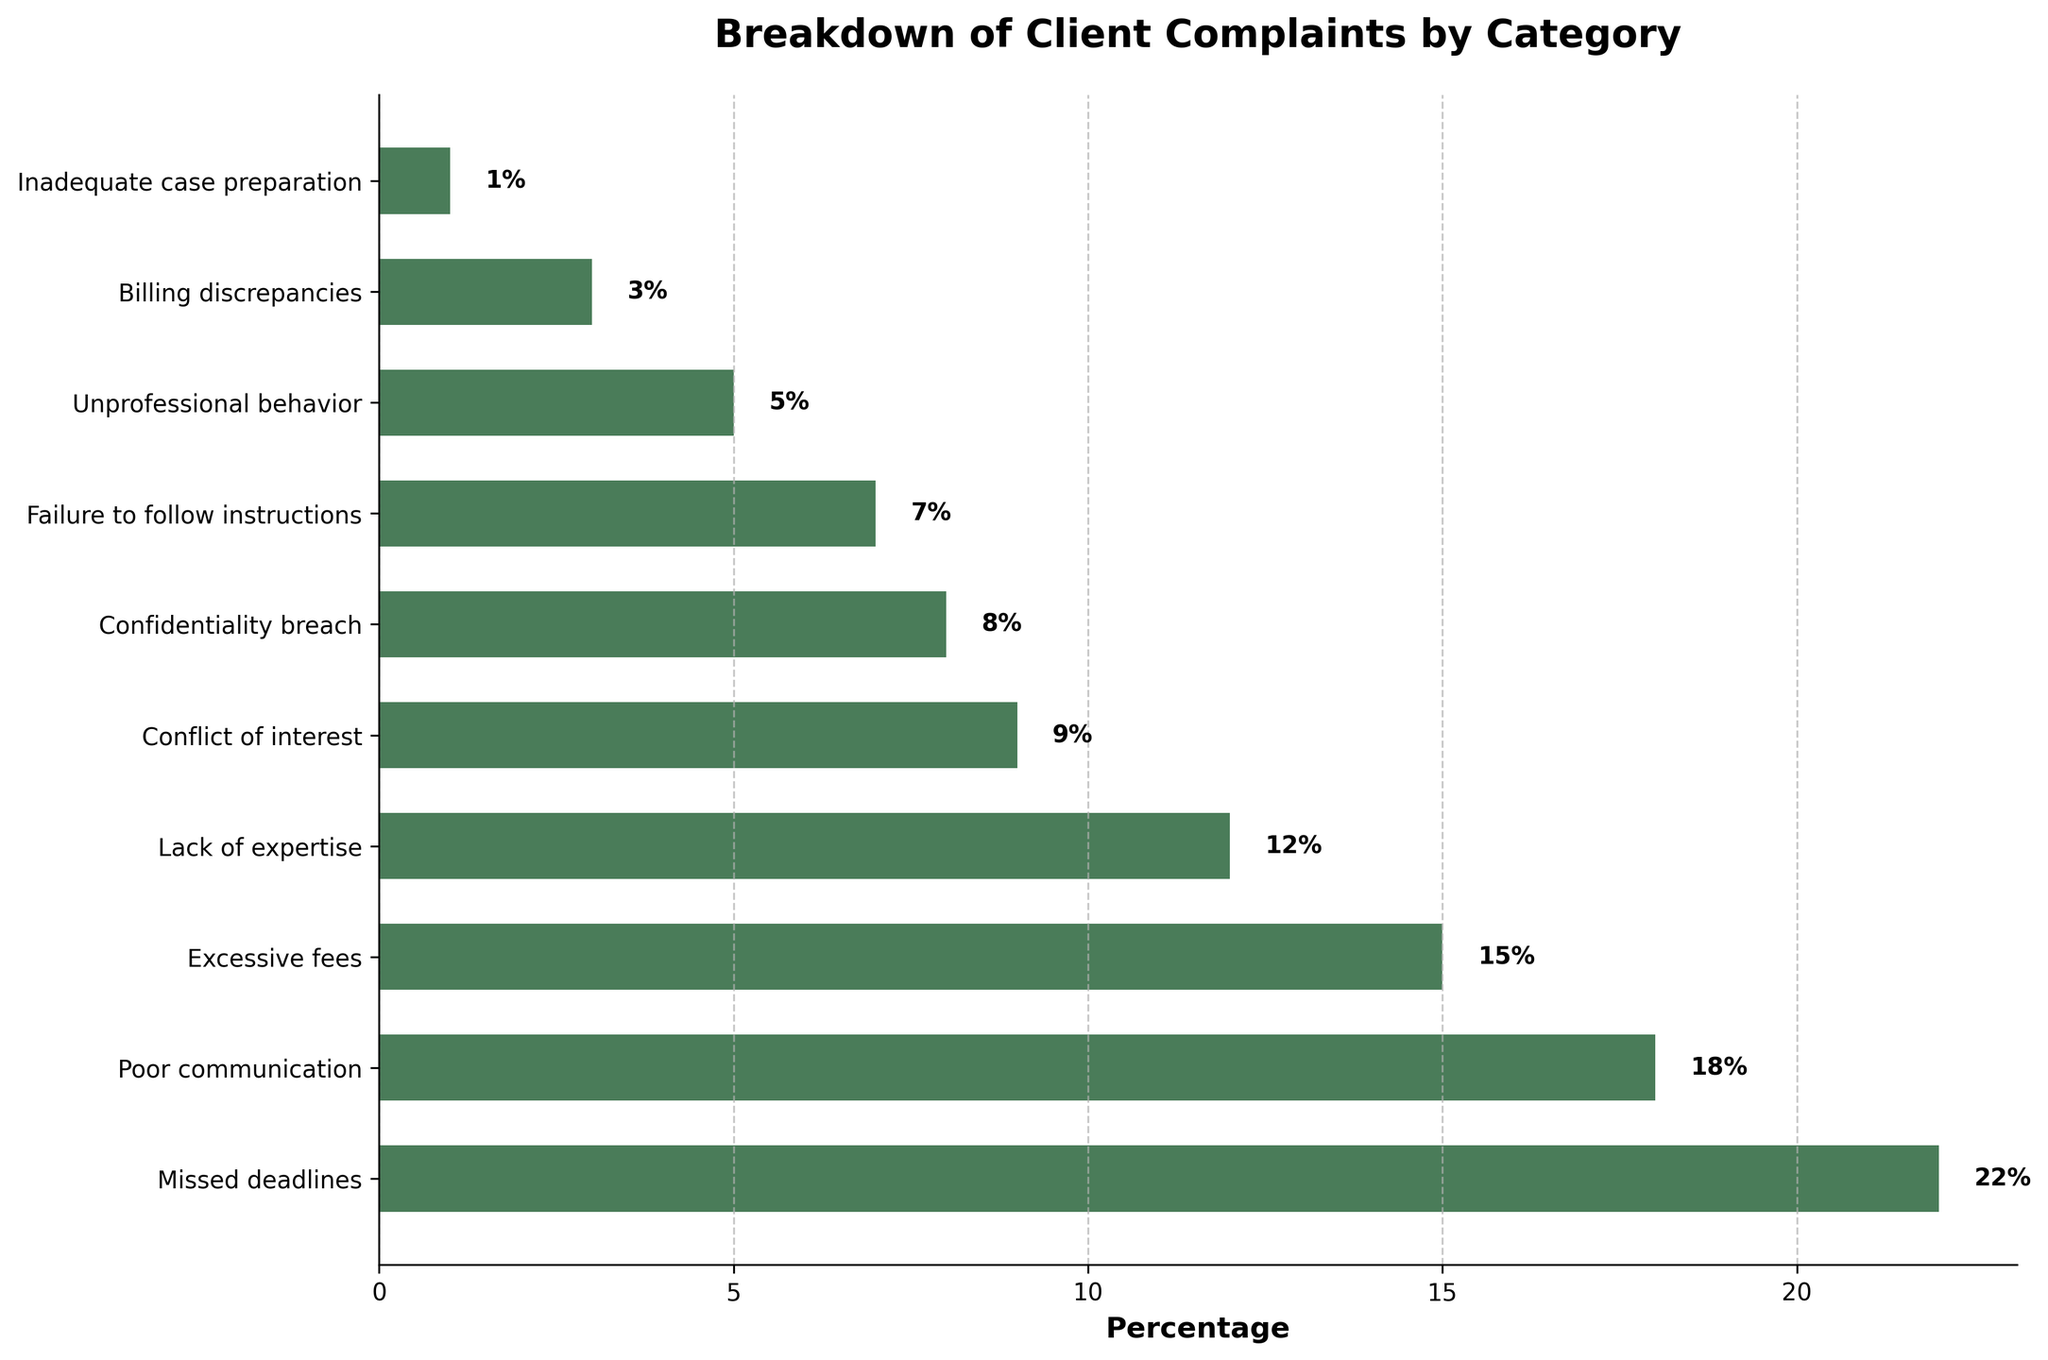What category has the highest percentage of client complaints? To find the category with the highest percentage, look for the longest bar in the horizontal bar chart. The category at the end of this bar will have the highest percentage.
Answer: Missed deadlines Which two categories combined make up exactly 20% of client complaints? Identify the bars corresponding to complaints and their percentages. Check which two categories' percentages sum up to 20%. The bars corresponding to "Failure to follow instructions" (7%) and "Unprofessional behavior" (5%), when added together, do not reach 20%. Adding the percentage of "Billing discrepancies" (3%) to this gives 15%. Further adding "Inadequate case preparation” (1%), still does not sum any pair to exactly 20%. Thus this requires proper examination of minor combination but doesn't match.
Answer: None Among "Poor communication" and "Excessive fees," which category has a higher percentage of client complaints? Compare the length of the bars for "Poor communication" and "Excessive fees." The bar that extends further to the right has a higher percentage.
Answer: Poor communication What is the total percentage of complaints accounted for by "Conflict of interest" and "Confidentiality breach"? Identify the bars for "Conflict of interest" and "Confidentiality breach," then sum their percentages: 9% + 8% = 17%.
Answer: 17% Which category has the lowest percentage of client complaints? Look for the shortest bar on the chart, which represents the smallest percentage. The category listed at the end of this bar has the lowest percentage.
Answer: Inadequate case preparation What is the difference in percentage between "Missed deadlines" and "Lack of expertise"? Identify the percentages for "Missed deadlines" and "Lack of expertise" and subtract the smaller percentage from the larger one: 22% - 12% = 10%.
Answer: 10% How many categories have a percentage of complaints 10% or higher? Count the number of bars that extend past the 10% mark on the horizontal axis.
Answer: 4 What percentage of complaints are related to issues with fees, combining "Excessive fees" and "Billing discrepancies"? Sum the percentages for "Excessive fees" and "Billing discrepancies": 15% + 3% = 18%.
Answer: 18% Do any of the categories have exactly the same percentage of complaints? Check the lengths of all bars to see if any of them are equal in length. In this particular chart, no two bars appear to be the same length.
Answer: No 